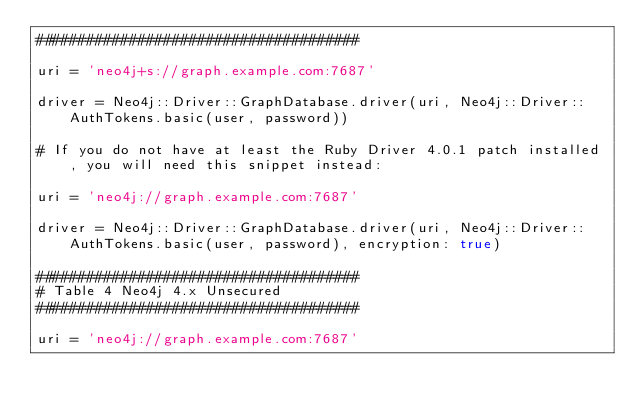<code> <loc_0><loc_0><loc_500><loc_500><_Ruby_>######################################

uri = 'neo4j+s://graph.example.com:7687'

driver = Neo4j::Driver::GraphDatabase.driver(uri, Neo4j::Driver::AuthTokens.basic(user, password))

# If you do not have at least the Ruby Driver 4.0.1 patch installed, you will need this snippet instead:

uri = 'neo4j://graph.example.com:7687'

driver = Neo4j::Driver::GraphDatabase.driver(uri, Neo4j::Driver::AuthTokens.basic(user, password), encryption: true)

######################################
# Table 4 Neo4j 4.x Unsecured
######################################

uri = 'neo4j://graph.example.com:7687'
</code> 